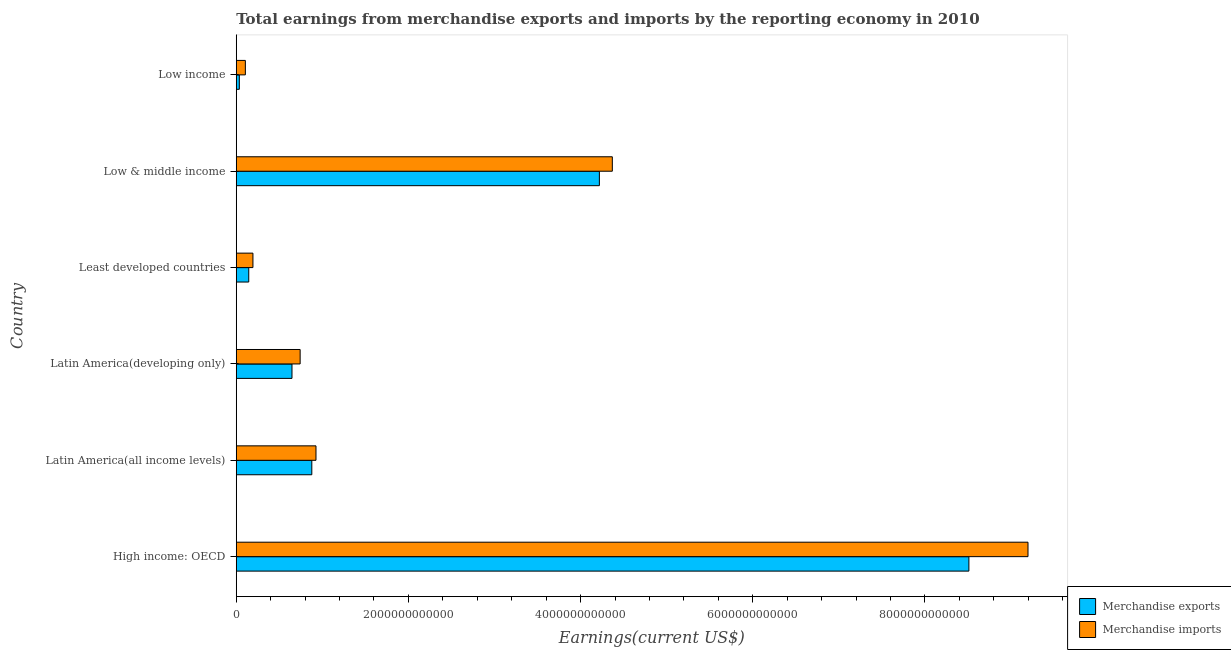How many groups of bars are there?
Provide a short and direct response. 6. Are the number of bars per tick equal to the number of legend labels?
Make the answer very short. Yes. How many bars are there on the 6th tick from the top?
Your answer should be compact. 2. What is the label of the 6th group of bars from the top?
Provide a succinct answer. High income: OECD. In how many cases, is the number of bars for a given country not equal to the number of legend labels?
Provide a short and direct response. 0. What is the earnings from merchandise imports in Low & middle income?
Your answer should be very brief. 4.37e+12. Across all countries, what is the maximum earnings from merchandise exports?
Give a very brief answer. 8.51e+12. Across all countries, what is the minimum earnings from merchandise imports?
Your response must be concise. 1.06e+11. In which country was the earnings from merchandise imports maximum?
Provide a short and direct response. High income: OECD. What is the total earnings from merchandise imports in the graph?
Your answer should be compact. 1.55e+13. What is the difference between the earnings from merchandise imports in High income: OECD and that in Latin America(all income levels)?
Give a very brief answer. 8.27e+12. What is the difference between the earnings from merchandise exports in Least developed countries and the earnings from merchandise imports in Low income?
Provide a short and direct response. 3.95e+1. What is the average earnings from merchandise exports per country?
Your response must be concise. 2.41e+12. What is the difference between the earnings from merchandise imports and earnings from merchandise exports in High income: OECD?
Offer a very short reply. 6.87e+11. In how many countries, is the earnings from merchandise imports greater than 2400000000000 US$?
Ensure brevity in your answer.  2. What is the ratio of the earnings from merchandise imports in High income: OECD to that in Least developed countries?
Your response must be concise. 47.44. Is the difference between the earnings from merchandise imports in High income: OECD and Low income greater than the difference between the earnings from merchandise exports in High income: OECD and Low income?
Give a very brief answer. Yes. What is the difference between the highest and the second highest earnings from merchandise imports?
Keep it short and to the point. 4.83e+12. What is the difference between the highest and the lowest earnings from merchandise exports?
Your response must be concise. 8.48e+12. In how many countries, is the earnings from merchandise imports greater than the average earnings from merchandise imports taken over all countries?
Make the answer very short. 2. Is the sum of the earnings from merchandise imports in Latin America(developing only) and Low & middle income greater than the maximum earnings from merchandise exports across all countries?
Ensure brevity in your answer.  No. What does the 2nd bar from the bottom in Low & middle income represents?
Your answer should be compact. Merchandise imports. How many bars are there?
Make the answer very short. 12. Are all the bars in the graph horizontal?
Your answer should be very brief. Yes. What is the difference between two consecutive major ticks on the X-axis?
Your answer should be compact. 2.00e+12. Are the values on the major ticks of X-axis written in scientific E-notation?
Offer a very short reply. No. Does the graph contain grids?
Keep it short and to the point. No. How are the legend labels stacked?
Make the answer very short. Vertical. What is the title of the graph?
Your response must be concise. Total earnings from merchandise exports and imports by the reporting economy in 2010. What is the label or title of the X-axis?
Offer a terse response. Earnings(current US$). What is the label or title of the Y-axis?
Your answer should be compact. Country. What is the Earnings(current US$) of Merchandise exports in High income: OECD?
Your response must be concise. 8.51e+12. What is the Earnings(current US$) of Merchandise imports in High income: OECD?
Offer a terse response. 9.20e+12. What is the Earnings(current US$) in Merchandise exports in Latin America(all income levels)?
Your response must be concise. 8.78e+11. What is the Earnings(current US$) in Merchandise imports in Latin America(all income levels)?
Make the answer very short. 9.26e+11. What is the Earnings(current US$) of Merchandise exports in Latin America(developing only)?
Keep it short and to the point. 6.47e+11. What is the Earnings(current US$) in Merchandise imports in Latin America(developing only)?
Offer a terse response. 7.42e+11. What is the Earnings(current US$) of Merchandise exports in Least developed countries?
Your response must be concise. 1.45e+11. What is the Earnings(current US$) in Merchandise imports in Least developed countries?
Your answer should be very brief. 1.94e+11. What is the Earnings(current US$) in Merchandise exports in Low & middle income?
Make the answer very short. 4.22e+12. What is the Earnings(current US$) in Merchandise imports in Low & middle income?
Keep it short and to the point. 4.37e+12. What is the Earnings(current US$) of Merchandise exports in Low income?
Offer a very short reply. 3.57e+1. What is the Earnings(current US$) of Merchandise imports in Low income?
Offer a very short reply. 1.06e+11. Across all countries, what is the maximum Earnings(current US$) of Merchandise exports?
Keep it short and to the point. 8.51e+12. Across all countries, what is the maximum Earnings(current US$) of Merchandise imports?
Offer a terse response. 9.20e+12. Across all countries, what is the minimum Earnings(current US$) of Merchandise exports?
Offer a very short reply. 3.57e+1. Across all countries, what is the minimum Earnings(current US$) of Merchandise imports?
Your answer should be compact. 1.06e+11. What is the total Earnings(current US$) of Merchandise exports in the graph?
Offer a very short reply. 1.44e+13. What is the total Earnings(current US$) of Merchandise imports in the graph?
Offer a very short reply. 1.55e+13. What is the difference between the Earnings(current US$) of Merchandise exports in High income: OECD and that in Latin America(all income levels)?
Provide a succinct answer. 7.63e+12. What is the difference between the Earnings(current US$) of Merchandise imports in High income: OECD and that in Latin America(all income levels)?
Your answer should be compact. 8.27e+12. What is the difference between the Earnings(current US$) of Merchandise exports in High income: OECD and that in Latin America(developing only)?
Make the answer very short. 7.86e+12. What is the difference between the Earnings(current US$) of Merchandise imports in High income: OECD and that in Latin America(developing only)?
Offer a terse response. 8.46e+12. What is the difference between the Earnings(current US$) of Merchandise exports in High income: OECD and that in Least developed countries?
Your answer should be compact. 8.37e+12. What is the difference between the Earnings(current US$) of Merchandise imports in High income: OECD and that in Least developed countries?
Your response must be concise. 9.00e+12. What is the difference between the Earnings(current US$) in Merchandise exports in High income: OECD and that in Low & middle income?
Your answer should be compact. 4.29e+12. What is the difference between the Earnings(current US$) in Merchandise imports in High income: OECD and that in Low & middle income?
Offer a very short reply. 4.83e+12. What is the difference between the Earnings(current US$) of Merchandise exports in High income: OECD and that in Low income?
Ensure brevity in your answer.  8.48e+12. What is the difference between the Earnings(current US$) in Merchandise imports in High income: OECD and that in Low income?
Your answer should be very brief. 9.09e+12. What is the difference between the Earnings(current US$) in Merchandise exports in Latin America(all income levels) and that in Latin America(developing only)?
Your answer should be very brief. 2.30e+11. What is the difference between the Earnings(current US$) in Merchandise imports in Latin America(all income levels) and that in Latin America(developing only)?
Provide a short and direct response. 1.84e+11. What is the difference between the Earnings(current US$) in Merchandise exports in Latin America(all income levels) and that in Least developed countries?
Your response must be concise. 7.33e+11. What is the difference between the Earnings(current US$) in Merchandise imports in Latin America(all income levels) and that in Least developed countries?
Provide a succinct answer. 7.32e+11. What is the difference between the Earnings(current US$) of Merchandise exports in Latin America(all income levels) and that in Low & middle income?
Make the answer very short. -3.34e+12. What is the difference between the Earnings(current US$) in Merchandise imports in Latin America(all income levels) and that in Low & middle income?
Offer a terse response. -3.44e+12. What is the difference between the Earnings(current US$) in Merchandise exports in Latin America(all income levels) and that in Low income?
Provide a short and direct response. 8.42e+11. What is the difference between the Earnings(current US$) of Merchandise imports in Latin America(all income levels) and that in Low income?
Provide a succinct answer. 8.21e+11. What is the difference between the Earnings(current US$) in Merchandise exports in Latin America(developing only) and that in Least developed countries?
Keep it short and to the point. 5.02e+11. What is the difference between the Earnings(current US$) of Merchandise imports in Latin America(developing only) and that in Least developed countries?
Give a very brief answer. 5.48e+11. What is the difference between the Earnings(current US$) of Merchandise exports in Latin America(developing only) and that in Low & middle income?
Offer a terse response. -3.57e+12. What is the difference between the Earnings(current US$) of Merchandise imports in Latin America(developing only) and that in Low & middle income?
Your answer should be compact. -3.63e+12. What is the difference between the Earnings(current US$) in Merchandise exports in Latin America(developing only) and that in Low income?
Ensure brevity in your answer.  6.12e+11. What is the difference between the Earnings(current US$) in Merchandise imports in Latin America(developing only) and that in Low income?
Your answer should be compact. 6.36e+11. What is the difference between the Earnings(current US$) of Merchandise exports in Least developed countries and that in Low & middle income?
Make the answer very short. -4.07e+12. What is the difference between the Earnings(current US$) of Merchandise imports in Least developed countries and that in Low & middle income?
Give a very brief answer. -4.18e+12. What is the difference between the Earnings(current US$) of Merchandise exports in Least developed countries and that in Low income?
Keep it short and to the point. 1.10e+11. What is the difference between the Earnings(current US$) of Merchandise imports in Least developed countries and that in Low income?
Keep it short and to the point. 8.81e+1. What is the difference between the Earnings(current US$) of Merchandise exports in Low & middle income and that in Low income?
Your response must be concise. 4.18e+12. What is the difference between the Earnings(current US$) of Merchandise imports in Low & middle income and that in Low income?
Your response must be concise. 4.26e+12. What is the difference between the Earnings(current US$) in Merchandise exports in High income: OECD and the Earnings(current US$) in Merchandise imports in Latin America(all income levels)?
Your answer should be compact. 7.58e+12. What is the difference between the Earnings(current US$) in Merchandise exports in High income: OECD and the Earnings(current US$) in Merchandise imports in Latin America(developing only)?
Provide a succinct answer. 7.77e+12. What is the difference between the Earnings(current US$) of Merchandise exports in High income: OECD and the Earnings(current US$) of Merchandise imports in Least developed countries?
Your answer should be very brief. 8.32e+12. What is the difference between the Earnings(current US$) in Merchandise exports in High income: OECD and the Earnings(current US$) in Merchandise imports in Low & middle income?
Give a very brief answer. 4.14e+12. What is the difference between the Earnings(current US$) in Merchandise exports in High income: OECD and the Earnings(current US$) in Merchandise imports in Low income?
Provide a succinct answer. 8.41e+12. What is the difference between the Earnings(current US$) of Merchandise exports in Latin America(all income levels) and the Earnings(current US$) of Merchandise imports in Latin America(developing only)?
Offer a terse response. 1.36e+11. What is the difference between the Earnings(current US$) of Merchandise exports in Latin America(all income levels) and the Earnings(current US$) of Merchandise imports in Least developed countries?
Offer a terse response. 6.84e+11. What is the difference between the Earnings(current US$) of Merchandise exports in Latin America(all income levels) and the Earnings(current US$) of Merchandise imports in Low & middle income?
Your response must be concise. -3.49e+12. What is the difference between the Earnings(current US$) in Merchandise exports in Latin America(all income levels) and the Earnings(current US$) in Merchandise imports in Low income?
Offer a very short reply. 7.72e+11. What is the difference between the Earnings(current US$) in Merchandise exports in Latin America(developing only) and the Earnings(current US$) in Merchandise imports in Least developed countries?
Provide a succinct answer. 4.54e+11. What is the difference between the Earnings(current US$) of Merchandise exports in Latin America(developing only) and the Earnings(current US$) of Merchandise imports in Low & middle income?
Keep it short and to the point. -3.72e+12. What is the difference between the Earnings(current US$) in Merchandise exports in Latin America(developing only) and the Earnings(current US$) in Merchandise imports in Low income?
Your answer should be very brief. 5.42e+11. What is the difference between the Earnings(current US$) in Merchandise exports in Least developed countries and the Earnings(current US$) in Merchandise imports in Low & middle income?
Give a very brief answer. -4.22e+12. What is the difference between the Earnings(current US$) of Merchandise exports in Least developed countries and the Earnings(current US$) of Merchandise imports in Low income?
Your response must be concise. 3.95e+1. What is the difference between the Earnings(current US$) of Merchandise exports in Low & middle income and the Earnings(current US$) of Merchandise imports in Low income?
Your response must be concise. 4.11e+12. What is the average Earnings(current US$) of Merchandise exports per country?
Offer a terse response. 2.41e+12. What is the average Earnings(current US$) in Merchandise imports per country?
Make the answer very short. 2.59e+12. What is the difference between the Earnings(current US$) of Merchandise exports and Earnings(current US$) of Merchandise imports in High income: OECD?
Ensure brevity in your answer.  -6.87e+11. What is the difference between the Earnings(current US$) in Merchandise exports and Earnings(current US$) in Merchandise imports in Latin America(all income levels)?
Your answer should be compact. -4.85e+1. What is the difference between the Earnings(current US$) in Merchandise exports and Earnings(current US$) in Merchandise imports in Latin America(developing only)?
Your answer should be compact. -9.47e+1. What is the difference between the Earnings(current US$) in Merchandise exports and Earnings(current US$) in Merchandise imports in Least developed countries?
Offer a terse response. -4.86e+1. What is the difference between the Earnings(current US$) in Merchandise exports and Earnings(current US$) in Merchandise imports in Low & middle income?
Give a very brief answer. -1.50e+11. What is the difference between the Earnings(current US$) of Merchandise exports and Earnings(current US$) of Merchandise imports in Low income?
Keep it short and to the point. -7.01e+1. What is the ratio of the Earnings(current US$) in Merchandise exports in High income: OECD to that in Latin America(all income levels)?
Provide a short and direct response. 9.7. What is the ratio of the Earnings(current US$) of Merchandise imports in High income: OECD to that in Latin America(all income levels)?
Your answer should be compact. 9.93. What is the ratio of the Earnings(current US$) in Merchandise exports in High income: OECD to that in Latin America(developing only)?
Keep it short and to the point. 13.15. What is the ratio of the Earnings(current US$) in Merchandise imports in High income: OECD to that in Latin America(developing only)?
Offer a terse response. 12.39. What is the ratio of the Earnings(current US$) in Merchandise exports in High income: OECD to that in Least developed countries?
Offer a terse response. 58.59. What is the ratio of the Earnings(current US$) in Merchandise imports in High income: OECD to that in Least developed countries?
Keep it short and to the point. 47.44. What is the ratio of the Earnings(current US$) in Merchandise exports in High income: OECD to that in Low & middle income?
Offer a terse response. 2.02. What is the ratio of the Earnings(current US$) of Merchandise imports in High income: OECD to that in Low & middle income?
Make the answer very short. 2.11. What is the ratio of the Earnings(current US$) of Merchandise exports in High income: OECD to that in Low income?
Offer a very short reply. 238.54. What is the ratio of the Earnings(current US$) in Merchandise imports in High income: OECD to that in Low income?
Provide a short and direct response. 86.97. What is the ratio of the Earnings(current US$) of Merchandise exports in Latin America(all income levels) to that in Latin America(developing only)?
Make the answer very short. 1.36. What is the ratio of the Earnings(current US$) of Merchandise imports in Latin America(all income levels) to that in Latin America(developing only)?
Offer a terse response. 1.25. What is the ratio of the Earnings(current US$) in Merchandise exports in Latin America(all income levels) to that in Least developed countries?
Your answer should be very brief. 6.04. What is the ratio of the Earnings(current US$) of Merchandise imports in Latin America(all income levels) to that in Least developed countries?
Ensure brevity in your answer.  4.78. What is the ratio of the Earnings(current US$) of Merchandise exports in Latin America(all income levels) to that in Low & middle income?
Give a very brief answer. 0.21. What is the ratio of the Earnings(current US$) in Merchandise imports in Latin America(all income levels) to that in Low & middle income?
Your answer should be compact. 0.21. What is the ratio of the Earnings(current US$) of Merchandise exports in Latin America(all income levels) to that in Low income?
Provide a short and direct response. 24.6. What is the ratio of the Earnings(current US$) in Merchandise imports in Latin America(all income levels) to that in Low income?
Your answer should be compact. 8.76. What is the ratio of the Earnings(current US$) in Merchandise exports in Latin America(developing only) to that in Least developed countries?
Provide a short and direct response. 4.46. What is the ratio of the Earnings(current US$) of Merchandise imports in Latin America(developing only) to that in Least developed countries?
Provide a succinct answer. 3.83. What is the ratio of the Earnings(current US$) of Merchandise exports in Latin America(developing only) to that in Low & middle income?
Give a very brief answer. 0.15. What is the ratio of the Earnings(current US$) in Merchandise imports in Latin America(developing only) to that in Low & middle income?
Keep it short and to the point. 0.17. What is the ratio of the Earnings(current US$) in Merchandise exports in Latin America(developing only) to that in Low income?
Your answer should be compact. 18.15. What is the ratio of the Earnings(current US$) of Merchandise imports in Latin America(developing only) to that in Low income?
Give a very brief answer. 7.02. What is the ratio of the Earnings(current US$) in Merchandise exports in Least developed countries to that in Low & middle income?
Offer a terse response. 0.03. What is the ratio of the Earnings(current US$) in Merchandise imports in Least developed countries to that in Low & middle income?
Provide a short and direct response. 0.04. What is the ratio of the Earnings(current US$) in Merchandise exports in Least developed countries to that in Low income?
Your response must be concise. 4.07. What is the ratio of the Earnings(current US$) in Merchandise imports in Least developed countries to that in Low income?
Your answer should be compact. 1.83. What is the ratio of the Earnings(current US$) of Merchandise exports in Low & middle income to that in Low income?
Provide a short and direct response. 118.23. What is the ratio of the Earnings(current US$) of Merchandise imports in Low & middle income to that in Low income?
Your answer should be compact. 41.31. What is the difference between the highest and the second highest Earnings(current US$) of Merchandise exports?
Provide a succinct answer. 4.29e+12. What is the difference between the highest and the second highest Earnings(current US$) of Merchandise imports?
Provide a succinct answer. 4.83e+12. What is the difference between the highest and the lowest Earnings(current US$) in Merchandise exports?
Provide a short and direct response. 8.48e+12. What is the difference between the highest and the lowest Earnings(current US$) of Merchandise imports?
Give a very brief answer. 9.09e+12. 